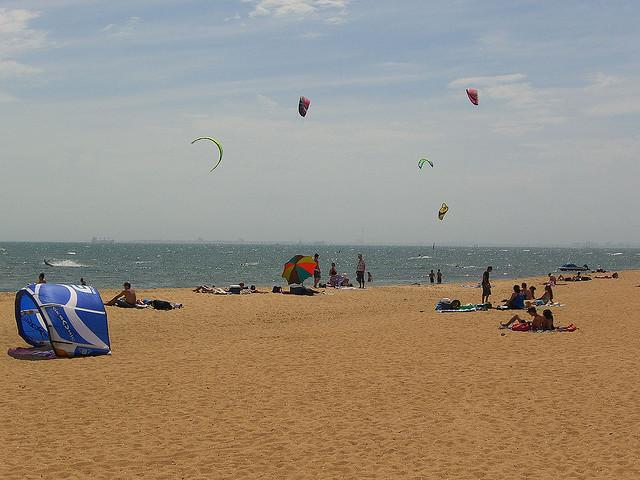What caused all the indents in the sand?

Choices:
A) foot traffic
B) acid rain
C) artillery fire
D) hail foot traffic 